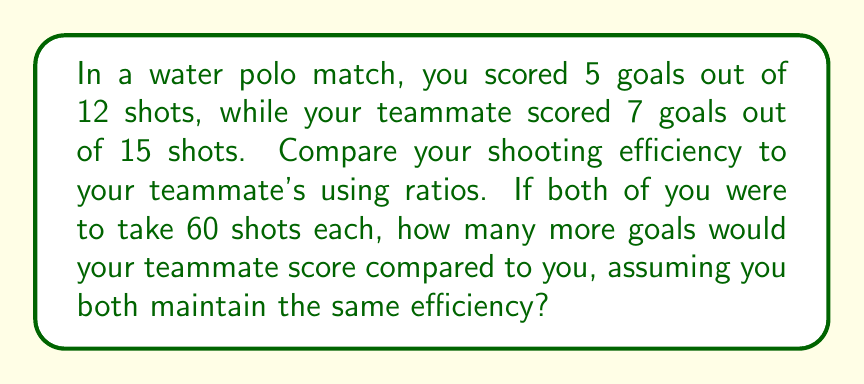Help me with this question. Let's approach this step-by-step:

1. Calculate the shooting efficiency ratios:
   Your efficiency: $\frac{5}{12}$
   Teammate's efficiency: $\frac{7}{15}$

2. To compare these ratios, we need to find a common denominator. The LCM of 12 and 15 is 60:
   Your efficiency: $\frac{5}{12} = \frac{5 \times 5}{12 \times 5} = \frac{25}{60}$
   Teammate's efficiency: $\frac{7}{15} = \frac{7 \times 4}{15 \times 4} = \frac{28}{60}$

3. Now we can easily compare: $\frac{28}{60} > \frac{25}{60}$, so your teammate has a higher efficiency.

4. To find out how many goals each would score in 60 shots:
   You: $60 \times \frac{25}{60} = 25$ goals
   Teammate: $60 \times \frac{28}{60} = 28$ goals

5. The difference in goals scored:
   $28 - 25 = 3$ goals

Therefore, if both of you were to take 60 shots each, your teammate would score 3 more goals than you, assuming you both maintain the same efficiency.
Answer: Your teammate would score 3 more goals than you if both took 60 shots each. 